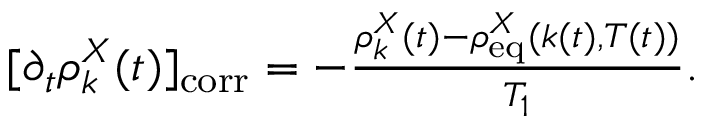Convert formula to latex. <formula><loc_0><loc_0><loc_500><loc_500>\begin{array} { r } { [ \partial _ { t } \rho _ { k } ^ { X } ( t ) ] _ { c o r r } = - \frac { \rho _ { k } ^ { X } ( t ) - \rho _ { e q } ^ { X } ( k ( t ) , T ( t ) ) } { T _ { 1 } } . } \end{array}</formula> 